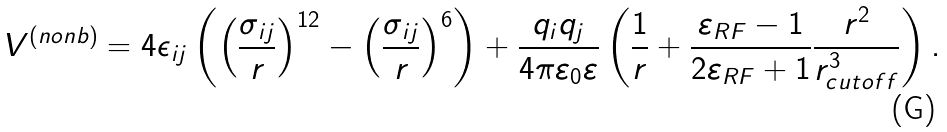Convert formula to latex. <formula><loc_0><loc_0><loc_500><loc_500>V ^ { ( n o n b ) } = 4 \epsilon _ { i j } \left ( \left ( \frac { \sigma _ { i j } } { r } \right ) ^ { 1 2 } - \left ( \frac { \sigma _ { i j } } { r } \right ) ^ { 6 } \right ) + \frac { q _ { i } q _ { j } } { 4 \pi \varepsilon _ { 0 } \varepsilon } \left ( \frac { 1 } { r } + \frac { \varepsilon _ { R F } - 1 } { 2 \varepsilon _ { R F } + 1 } \frac { r ^ { 2 } } { r _ { c u t o f f } ^ { 3 } } \right ) .</formula> 